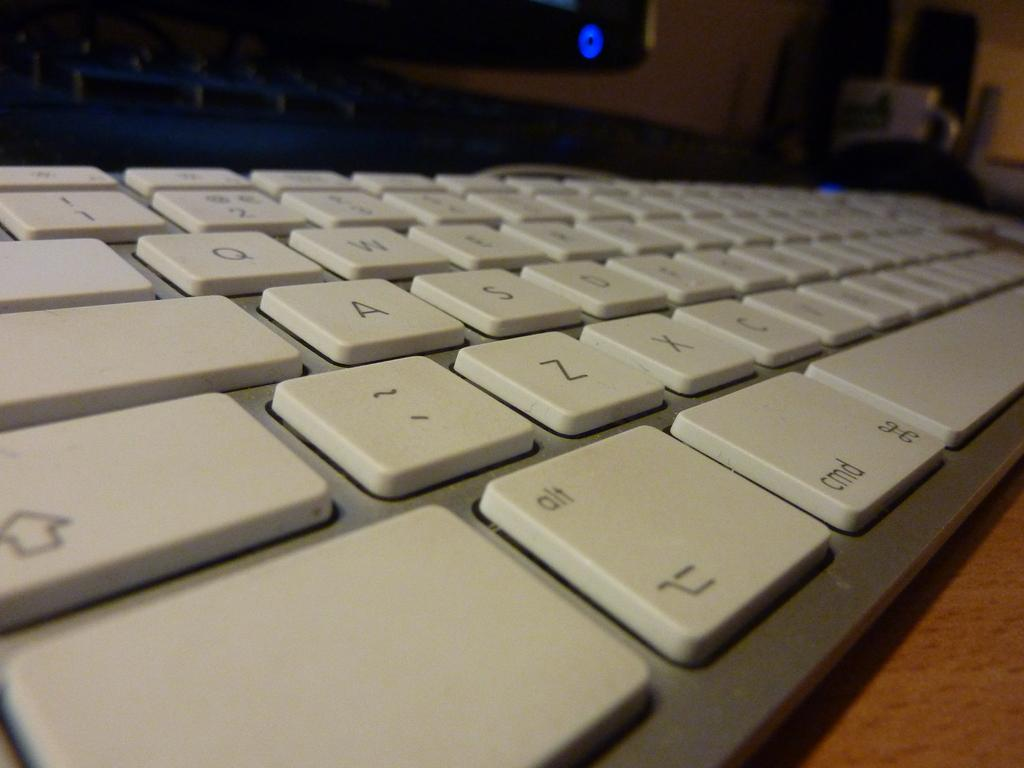<image>
Render a clear and concise summary of the photo. A keyboard with alt button next to the cmd button. 